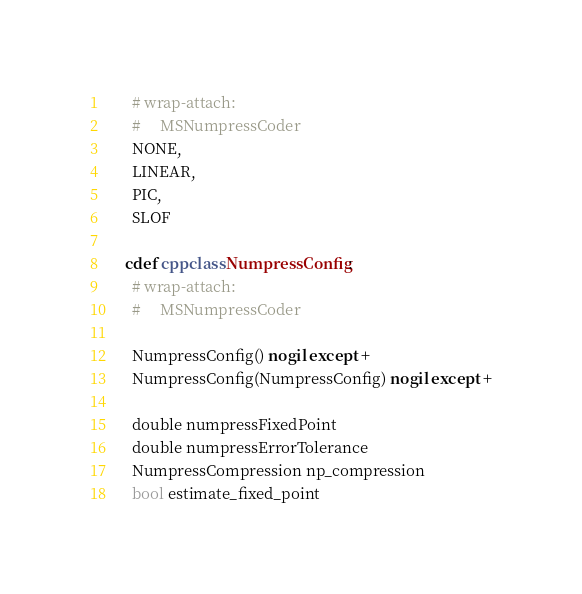<code> <loc_0><loc_0><loc_500><loc_500><_Cython_>      # wrap-attach:
      #     MSNumpressCoder
      NONE,
      LINEAR,
      PIC,
      SLOF

    cdef cppclass NumpressConfig:
      # wrap-attach:
      #     MSNumpressCoder

      NumpressConfig() nogil except +
      NumpressConfig(NumpressConfig) nogil except +

      double numpressFixedPoint
      double numpressErrorTolerance
      NumpressCompression np_compression
      bool estimate_fixed_point

</code> 